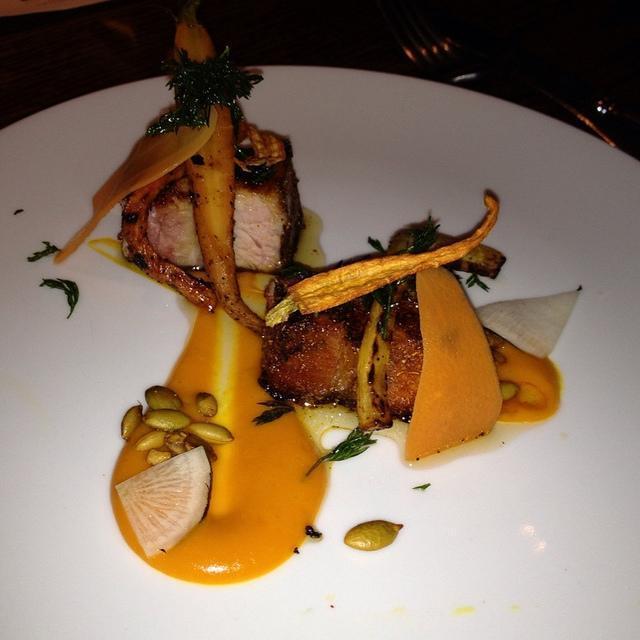How many carrots are in the photo?
Give a very brief answer. 2. 